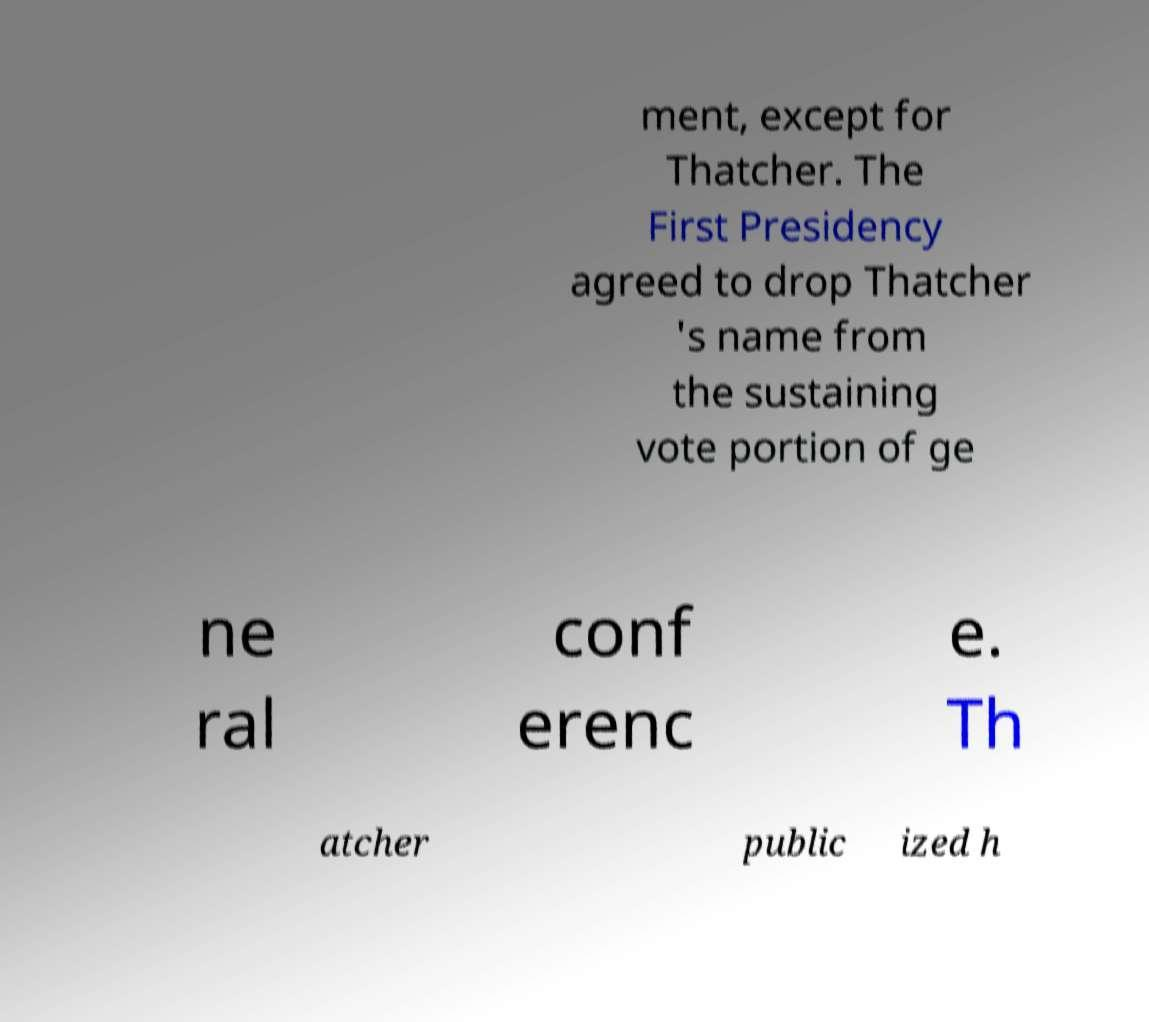Please read and relay the text visible in this image. What does it say? ment, except for Thatcher. The First Presidency agreed to drop Thatcher 's name from the sustaining vote portion of ge ne ral conf erenc e. Th atcher public ized h 